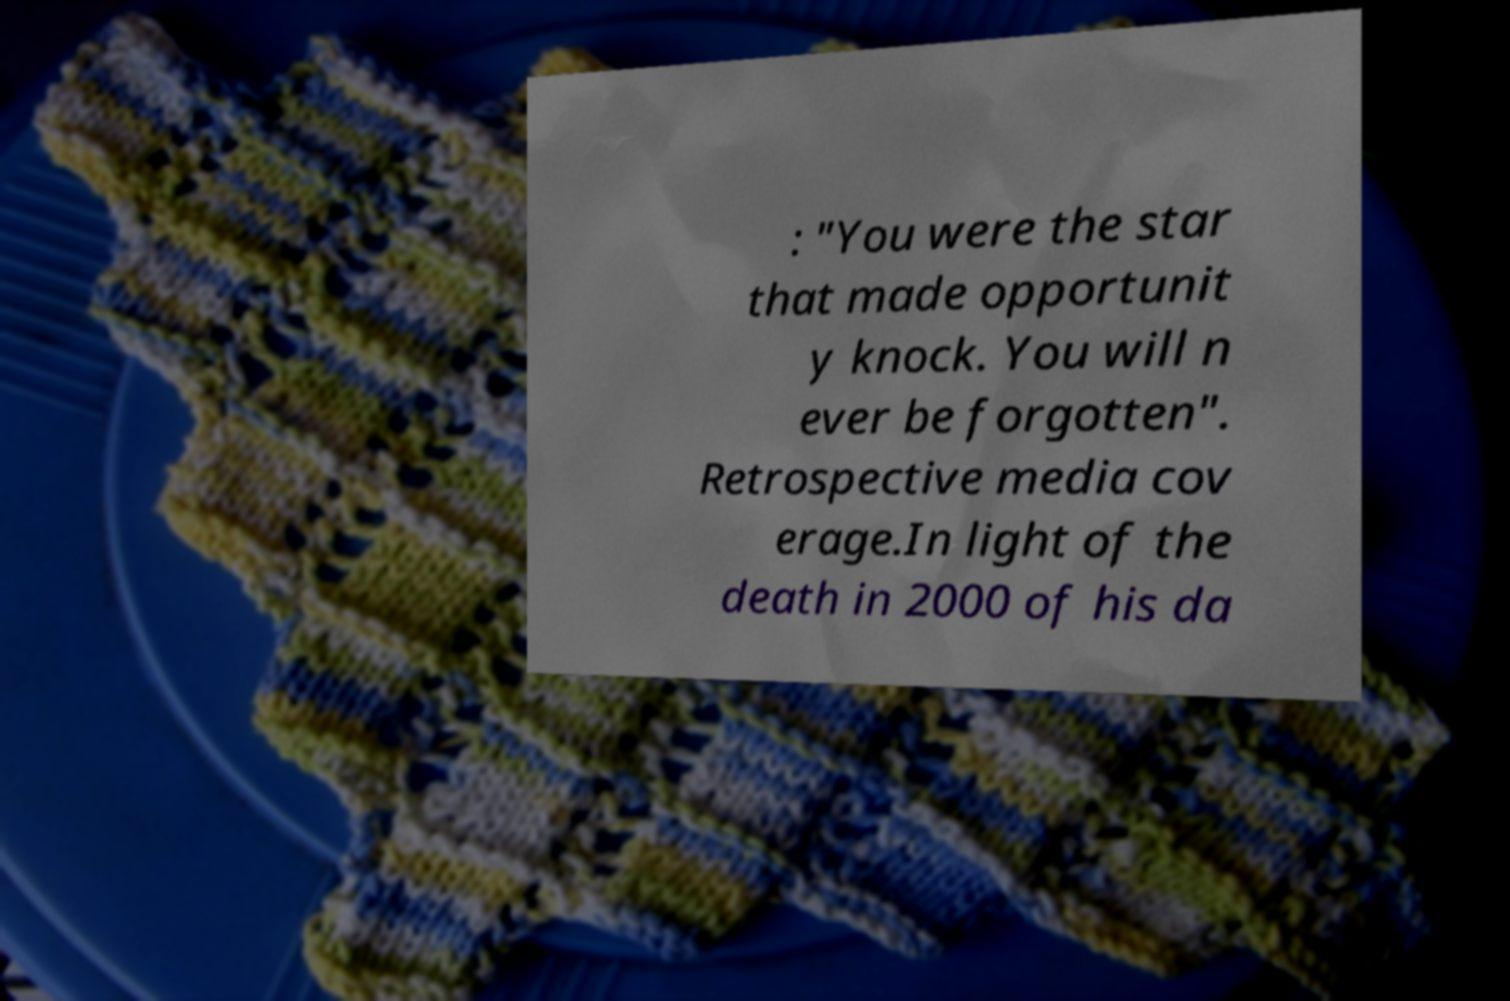Please identify and transcribe the text found in this image. : "You were the star that made opportunit y knock. You will n ever be forgotten". Retrospective media cov erage.In light of the death in 2000 of his da 